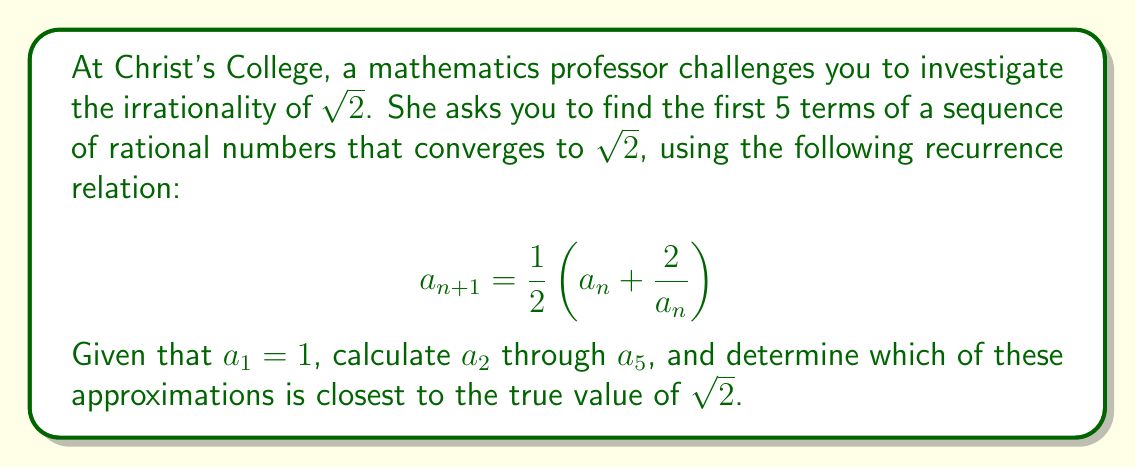Can you solve this math problem? Let's approach this step-by-step:

1) We start with $a_1 = 1$

2) To find $a_2$:
   $$a_2 = \frac{1}{2}\left(a_1 + \frac{2}{a_1}\right) = \frac{1}{2}\left(1 + \frac{2}{1}\right) = \frac{1}{2}(1 + 2) = \frac{3}{2} = 1.5$$

3) For $a_3$:
   $$a_3 = \frac{1}{2}\left(a_2 + \frac{2}{a_2}\right) = \frac{1}{2}\left(\frac{3}{2} + \frac{2}{\frac{3}{2}}\right) = \frac{1}{2}\left(\frac{3}{2} + \frac{4}{3}\right) = \frac{1}{2} \cdot \frac{17}{6} = \frac{17}{12} \approx 1.4166667$$

4) For $a_4$:
   $$a_4 = \frac{1}{2}\left(a_3 + \frac{2}{a_3}\right) = \frac{1}{2}\left(\frac{17}{12} + \frac{2}{\frac{17}{12}}\right) = \frac{1}{2}\left(\frac{17}{12} + \frac{24}{17}\right) = \frac{577}{408} \approx 1.4142157$$

5) For $a_5$:
   $$a_5 = \frac{1}{2}\left(a_4 + \frac{2}{a_4}\right) = \frac{1}{2}\left(\frac{577}{408} + \frac{2}{\frac{577}{408}}\right) = \frac{665857}{470832} \approx 1.4142136$$

6) The true value of $\sqrt{2}$ to 10 decimal places is approximately 1.4142135624.

7) Comparing our approximations:
   $a_1 = 1$
   $a_2 = 1.5$
   $a_3 \approx 1.4166667$
   $a_4 \approx 1.4142157$
   $a_5 \approx 1.4142136$

We can see that each term gets closer to $\sqrt{2}$, with $a_5$ being the closest approximation.

This sequence is known as the Babylonian method or Heron's method for approximating square roots, and it converges quadratically to $\sqrt{2}$.
Answer: The first 5 terms of the sequence are:
$a_1 = 1$
$a_2 = \frac{3}{2} = 1.5$
$a_3 = \frac{17}{12} \approx 1.4166667$
$a_4 = \frac{577}{408} \approx 1.4142157$
$a_5 = \frac{665857}{470832} \approx 1.4142136$

The closest approximation to $\sqrt{2}$ is $a_5 = \frac{665857}{470832}$. 